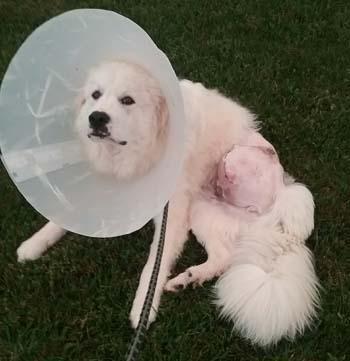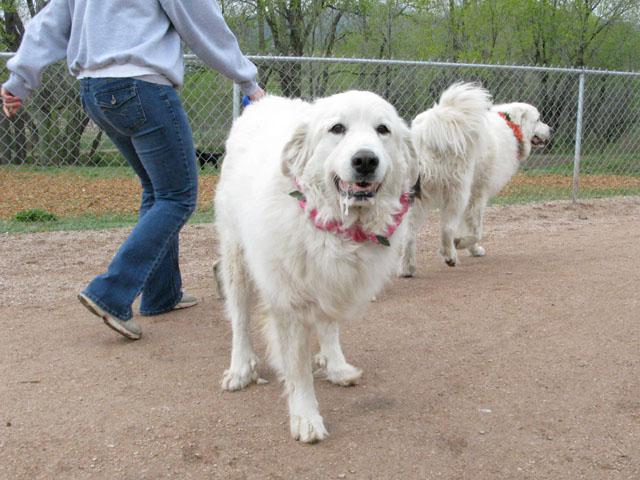The first image is the image on the left, the second image is the image on the right. Given the left and right images, does the statement "There are at most two dogs." hold true? Answer yes or no. No. The first image is the image on the left, the second image is the image on the right. Assess this claim about the two images: "The images together contain no more than two dogs.". Correct or not? Answer yes or no. No. 